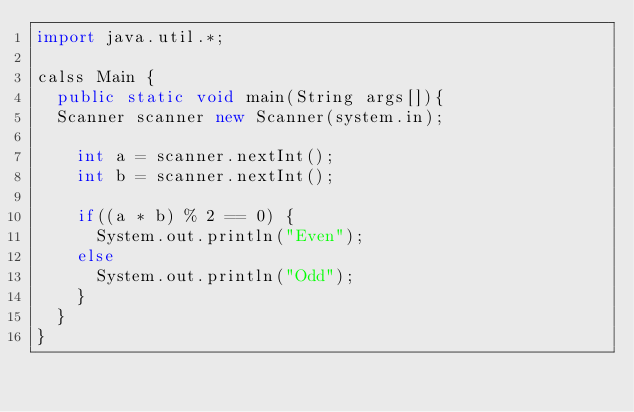Convert code to text. <code><loc_0><loc_0><loc_500><loc_500><_Java_>import java.util.*;
 
calss Main {
  public static void main(String args[]){
	Scanner scanner new Scanner(system.in);
    
    int a = scanner.nextInt();
    int b = scanner.nextInt();
    
    if((a * b) % 2 == 0) {
      System.out.println("Even");
    else
      System.out.println("Odd");
    }
  }
}
    </code> 